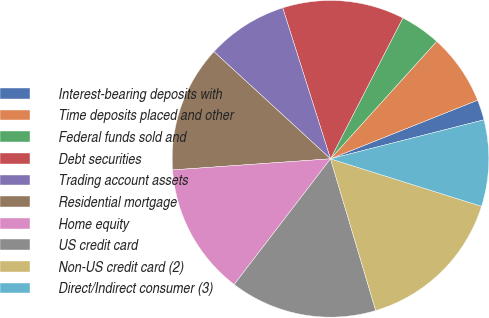<chart> <loc_0><loc_0><loc_500><loc_500><pie_chart><fcel>Interest-bearing deposits with<fcel>Time deposits placed and other<fcel>Federal funds sold and<fcel>Debt securities<fcel>Trading account assets<fcel>Residential mortgage<fcel>Home equity<fcel>US credit card<fcel>Non-US credit card (2)<fcel>Direct/Indirect consumer (3)<nl><fcel>2.08%<fcel>7.26%<fcel>4.15%<fcel>12.43%<fcel>8.29%<fcel>12.95%<fcel>13.47%<fcel>15.02%<fcel>15.54%<fcel>8.81%<nl></chart> 